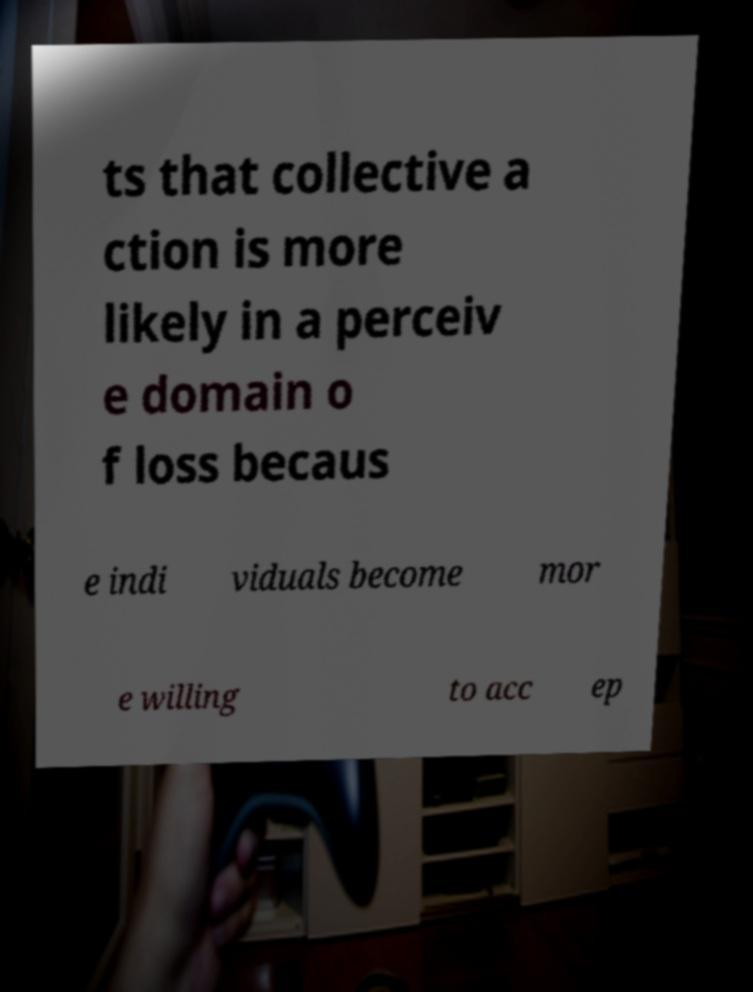I need the written content from this picture converted into text. Can you do that? ts that collective a ction is more likely in a perceiv e domain o f loss becaus e indi viduals become mor e willing to acc ep 